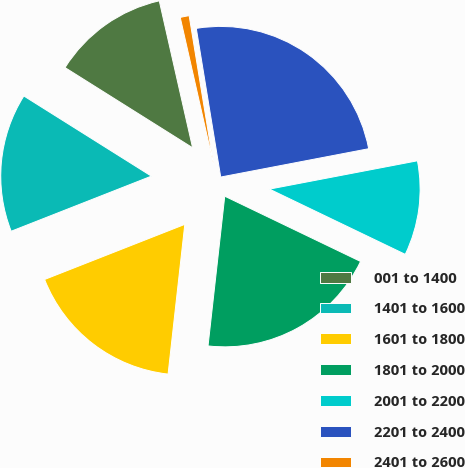Convert chart. <chart><loc_0><loc_0><loc_500><loc_500><pie_chart><fcel>001 to 1400<fcel>1401 to 1600<fcel>1601 to 1800<fcel>1801 to 2000<fcel>2001 to 2200<fcel>2201 to 2400<fcel>2401 to 2600<nl><fcel>12.52%<fcel>14.89%<fcel>17.27%<fcel>19.64%<fcel>10.14%<fcel>24.58%<fcel>0.96%<nl></chart> 